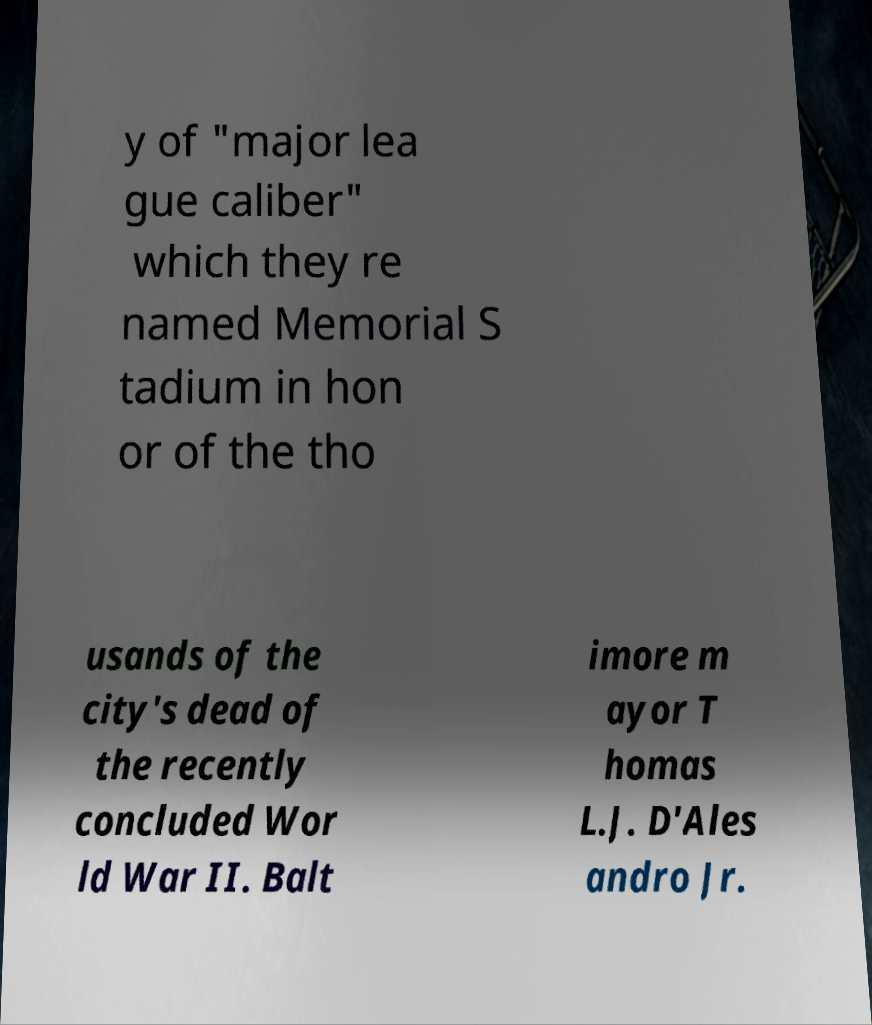Please read and relay the text visible in this image. What does it say? y of "major lea gue caliber" which they re named Memorial S tadium in hon or of the tho usands of the city's dead of the recently concluded Wor ld War II. Balt imore m ayor T homas L.J. D'Ales andro Jr. 